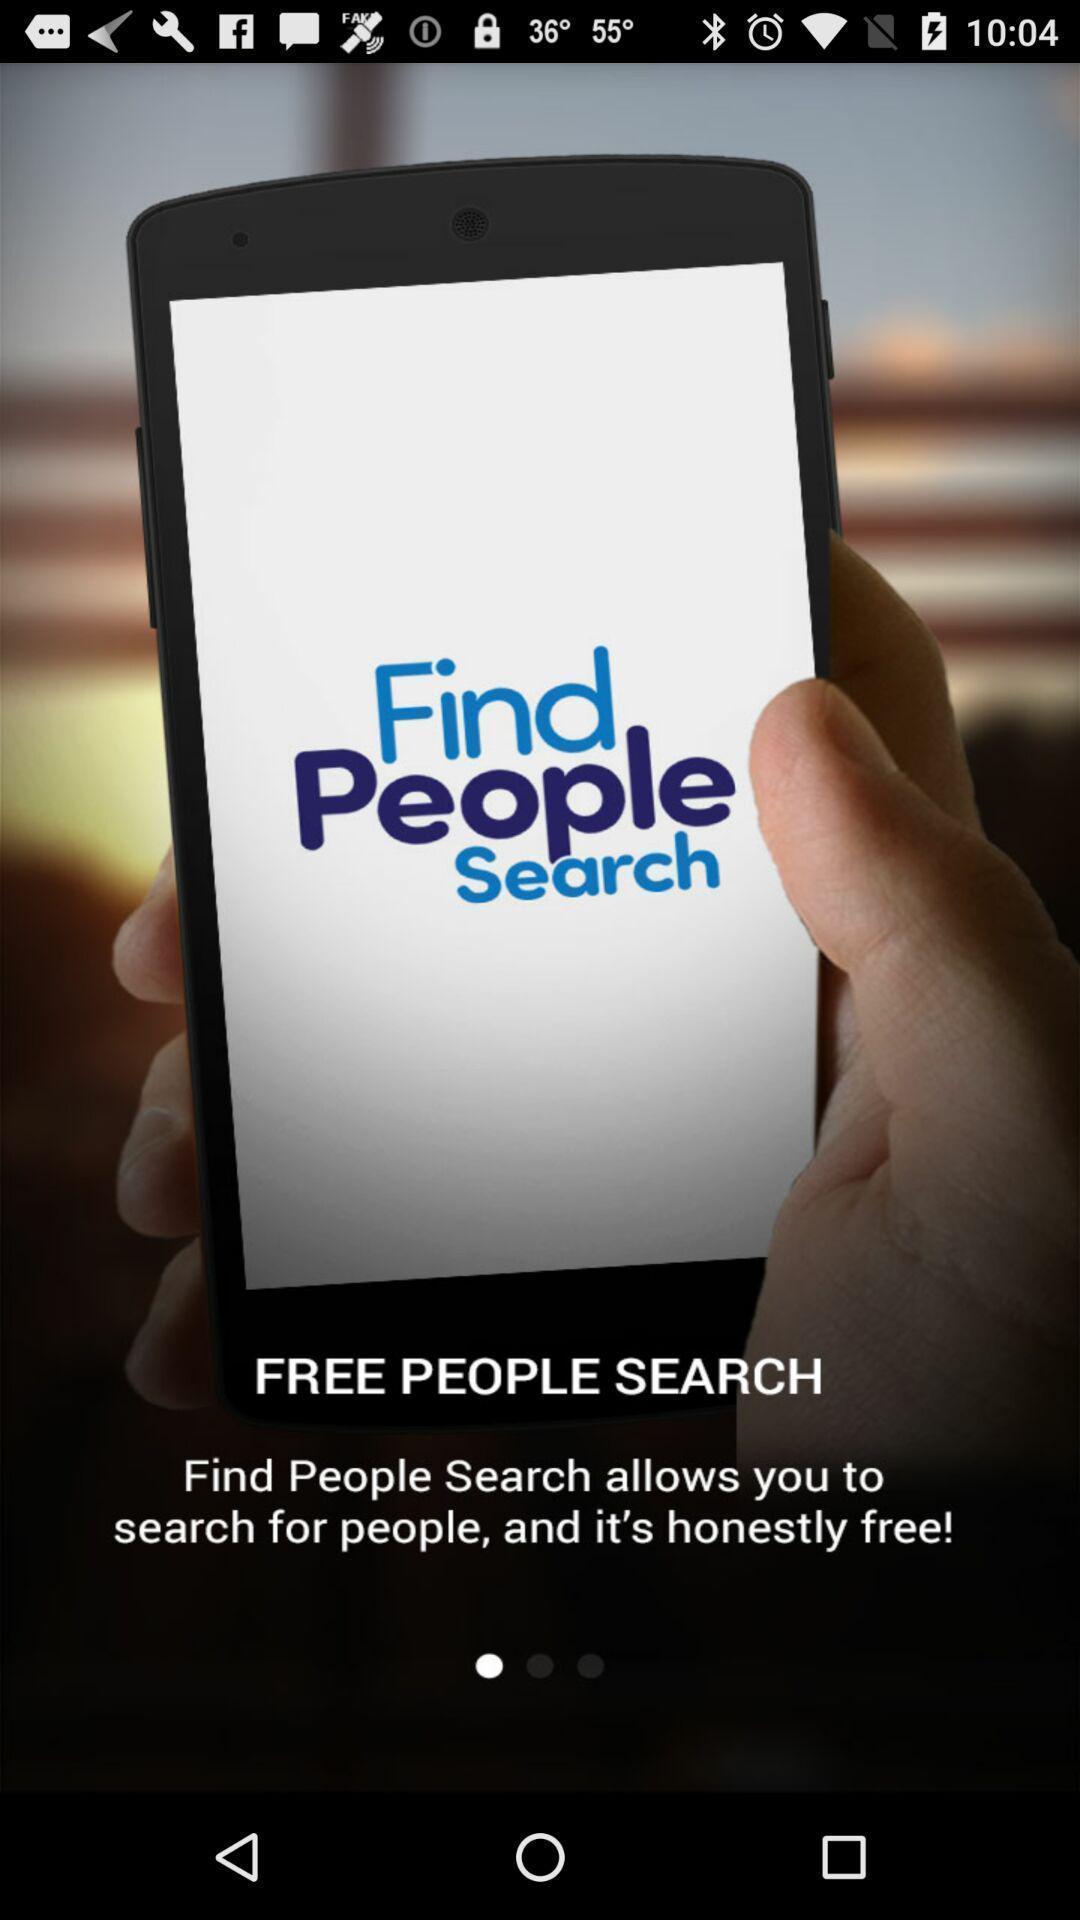Give me a summary of this screen capture. Welcome page of a tracking app. 